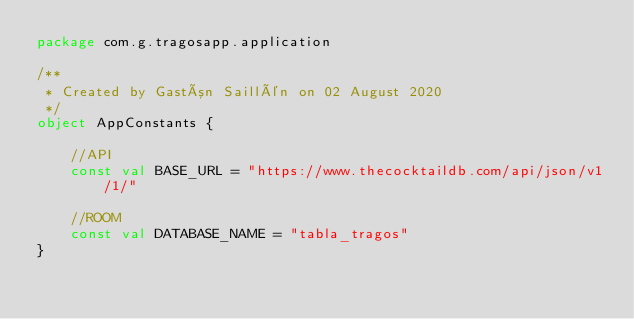Convert code to text. <code><loc_0><loc_0><loc_500><loc_500><_Kotlin_>package com.g.tragosapp.application

/**
 * Created by Gastón Saillén on 02 August 2020
 */
object AppConstants {

    //API
    const val BASE_URL = "https://www.thecocktaildb.com/api/json/v1/1/"

    //ROOM
    const val DATABASE_NAME = "tabla_tragos"
}</code> 